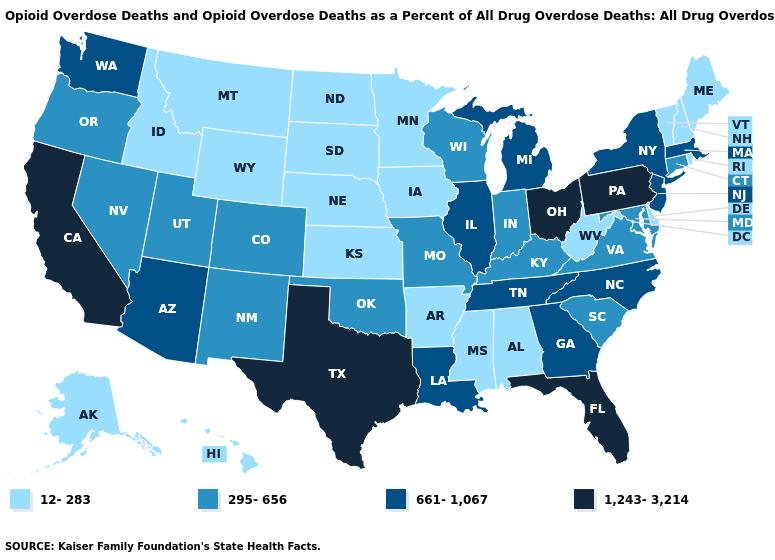Name the states that have a value in the range 295-656?
Quick response, please. Colorado, Connecticut, Indiana, Kentucky, Maryland, Missouri, Nevada, New Mexico, Oklahoma, Oregon, South Carolina, Utah, Virginia, Wisconsin. Does New Hampshire have the lowest value in the USA?
Answer briefly. Yes. What is the highest value in states that border Kentucky?
Concise answer only. 1,243-3,214. Which states have the highest value in the USA?
Be succinct. California, Florida, Ohio, Pennsylvania, Texas. Does Colorado have a lower value than Alaska?
Keep it brief. No. Name the states that have a value in the range 661-1,067?
Concise answer only. Arizona, Georgia, Illinois, Louisiana, Massachusetts, Michigan, New Jersey, New York, North Carolina, Tennessee, Washington. Does Colorado have a higher value than Ohio?
Answer briefly. No. What is the highest value in the USA?
Write a very short answer. 1,243-3,214. How many symbols are there in the legend?
Write a very short answer. 4. Name the states that have a value in the range 661-1,067?
Quick response, please. Arizona, Georgia, Illinois, Louisiana, Massachusetts, Michigan, New Jersey, New York, North Carolina, Tennessee, Washington. What is the lowest value in the Northeast?
Give a very brief answer. 12-283. Name the states that have a value in the range 295-656?
Answer briefly. Colorado, Connecticut, Indiana, Kentucky, Maryland, Missouri, Nevada, New Mexico, Oklahoma, Oregon, South Carolina, Utah, Virginia, Wisconsin. What is the value of Alaska?
Give a very brief answer. 12-283. What is the value of Minnesota?
Give a very brief answer. 12-283. Name the states that have a value in the range 661-1,067?
Be succinct. Arizona, Georgia, Illinois, Louisiana, Massachusetts, Michigan, New Jersey, New York, North Carolina, Tennessee, Washington. 